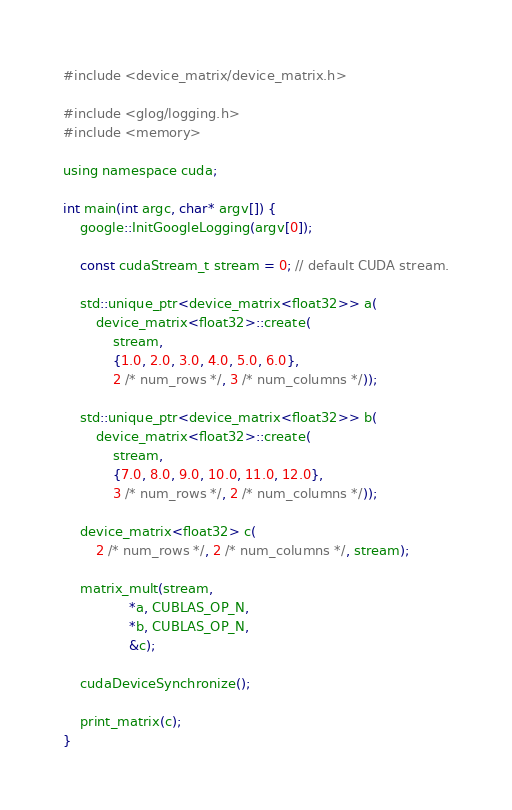<code> <loc_0><loc_0><loc_500><loc_500><_Cuda_>#include <device_matrix/device_matrix.h>

#include <glog/logging.h>
#include <memory>

using namespace cuda;

int main(int argc, char* argv[]) {
    google::InitGoogleLogging(argv[0]);

    const cudaStream_t stream = 0; // default CUDA stream.

    std::unique_ptr<device_matrix<float32>> a(
        device_matrix<float32>::create(
            stream,
            {1.0, 2.0, 3.0, 4.0, 5.0, 6.0},
            2 /* num_rows */, 3 /* num_columns */));

    std::unique_ptr<device_matrix<float32>> b(
        device_matrix<float32>::create(
            stream,
            {7.0, 8.0, 9.0, 10.0, 11.0, 12.0},
            3 /* num_rows */, 2 /* num_columns */));

    device_matrix<float32> c(
        2 /* num_rows */, 2 /* num_columns */, stream);

    matrix_mult(stream,
                *a, CUBLAS_OP_N,
                *b, CUBLAS_OP_N,
                &c);

    cudaDeviceSynchronize();

    print_matrix(c);
}
</code> 